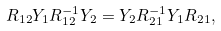Convert formula to latex. <formula><loc_0><loc_0><loc_500><loc_500>R _ { 1 2 } Y _ { 1 } R _ { 1 2 } ^ { - 1 } Y _ { 2 } = Y _ { 2 } R _ { 2 1 } ^ { - 1 } Y _ { 1 } R _ { 2 1 } ,</formula> 